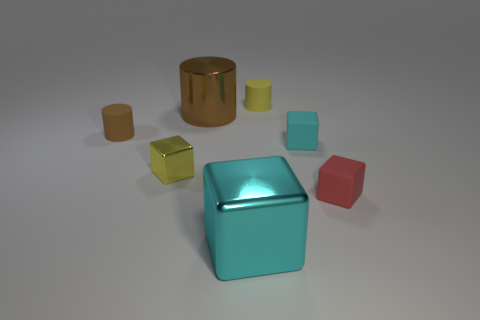There is a rubber object that is the same color as the tiny metal thing; what is its shape? The rubber object and the small metal item share a turquoise color, and the shape of the rubber object is a cylinder, similar but not identical to the shape of a classic rubber eraser typically used to remove pencil marks. 